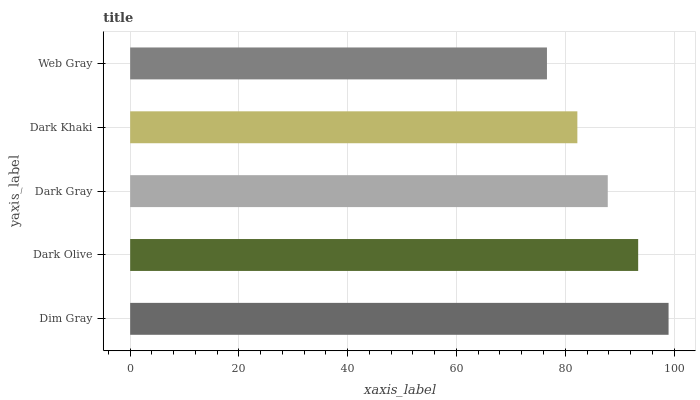Is Web Gray the minimum?
Answer yes or no. Yes. Is Dim Gray the maximum?
Answer yes or no. Yes. Is Dark Olive the minimum?
Answer yes or no. No. Is Dark Olive the maximum?
Answer yes or no. No. Is Dim Gray greater than Dark Olive?
Answer yes or no. Yes. Is Dark Olive less than Dim Gray?
Answer yes or no. Yes. Is Dark Olive greater than Dim Gray?
Answer yes or no. No. Is Dim Gray less than Dark Olive?
Answer yes or no. No. Is Dark Gray the high median?
Answer yes or no. Yes. Is Dark Gray the low median?
Answer yes or no. Yes. Is Web Gray the high median?
Answer yes or no. No. Is Dim Gray the low median?
Answer yes or no. No. 